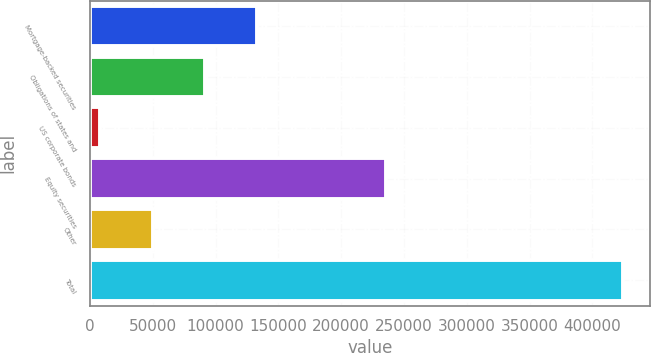Convert chart to OTSL. <chart><loc_0><loc_0><loc_500><loc_500><bar_chart><fcel>Mortgage-backed securities<fcel>Obligations of states and<fcel>US corporate bonds<fcel>Equity securities<fcel>Other<fcel>Total<nl><fcel>133134<fcel>91509<fcel>8260<fcel>235659<fcel>49884.5<fcel>424505<nl></chart> 